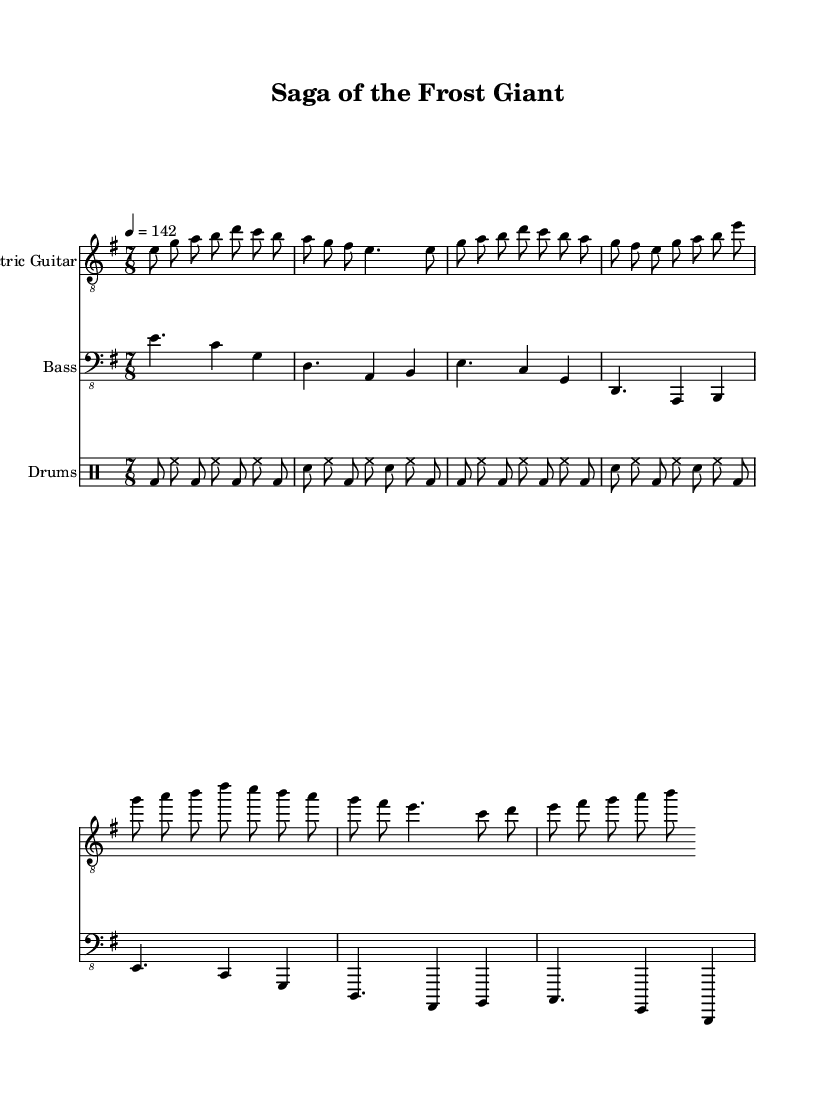What is the key signature of this music? The key signature is E minor, indicated by one sharp (F#) on the left side of the staff.
Answer: E minor What is the time signature of this music? The time signature is 7/8, shown at the beginning of the score. It indicates that there are seven eighth notes per measure.
Answer: 7/8 What is the tempo marking for this piece? The tempo marking indicates a quarter note equals 142 beats per minute, shown at the top of the score.
Answer: 142 How many measures are in the "Intro" section? The "Intro" consists of two measures. Each measure contains a distinct set of notes, evident from the notation.
Answer: 2 Which section contains a bridge? The bridge is indicated as "Bridge (partial)" in the electric guitar part. It follows the routine patterns of the verse and chorus, transitioning into new material.
Answer: Bridge What type of drum pattern is mostly used? The drum pattern is a basic rock pattern that features combinations of bass and snare drum played in eighth notes, which creates a steady driving rhythm typical in metal music.
Answer: Basic drum pattern What main thematic element does this piece suggest from its title? The title "Saga of the Frost Giant" suggests a narrative with literary influences, possibly referencing mythology or epic storytelling, which is common in progressive metal.
Answer: Literature-based narrative 